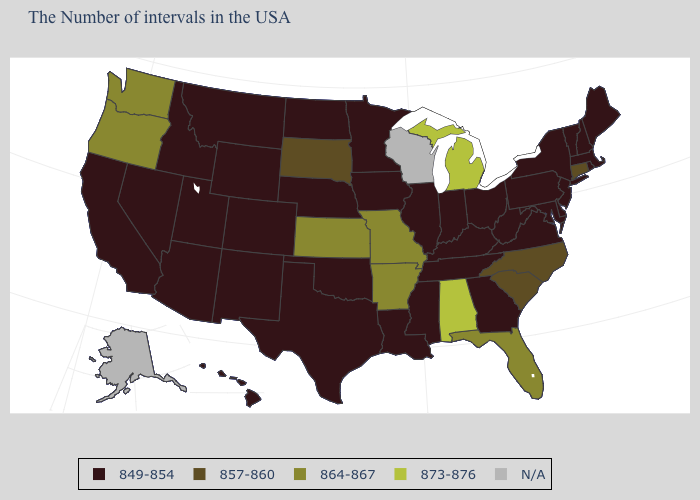Name the states that have a value in the range 849-854?
Keep it brief. Maine, Massachusetts, Rhode Island, New Hampshire, Vermont, New York, New Jersey, Delaware, Maryland, Pennsylvania, Virginia, West Virginia, Ohio, Georgia, Kentucky, Indiana, Tennessee, Illinois, Mississippi, Louisiana, Minnesota, Iowa, Nebraska, Oklahoma, Texas, North Dakota, Wyoming, Colorado, New Mexico, Utah, Montana, Arizona, Idaho, Nevada, California, Hawaii. Among the states that border New York , does Connecticut have the highest value?
Give a very brief answer. Yes. Does the map have missing data?
Write a very short answer. Yes. Name the states that have a value in the range 873-876?
Answer briefly. Michigan, Alabama. Among the states that border Massachusetts , which have the highest value?
Answer briefly. Connecticut. Among the states that border Oregon , does Washington have the highest value?
Give a very brief answer. Yes. What is the highest value in states that border New Jersey?
Be succinct. 849-854. Does Alabama have the lowest value in the USA?
Give a very brief answer. No. What is the lowest value in the Northeast?
Short answer required. 849-854. Name the states that have a value in the range 873-876?
Write a very short answer. Michigan, Alabama. Which states have the lowest value in the USA?
Be succinct. Maine, Massachusetts, Rhode Island, New Hampshire, Vermont, New York, New Jersey, Delaware, Maryland, Pennsylvania, Virginia, West Virginia, Ohio, Georgia, Kentucky, Indiana, Tennessee, Illinois, Mississippi, Louisiana, Minnesota, Iowa, Nebraska, Oklahoma, Texas, North Dakota, Wyoming, Colorado, New Mexico, Utah, Montana, Arizona, Idaho, Nevada, California, Hawaii. What is the highest value in the USA?
Be succinct. 873-876. Name the states that have a value in the range 873-876?
Keep it brief. Michigan, Alabama. What is the value of Florida?
Give a very brief answer. 864-867. 